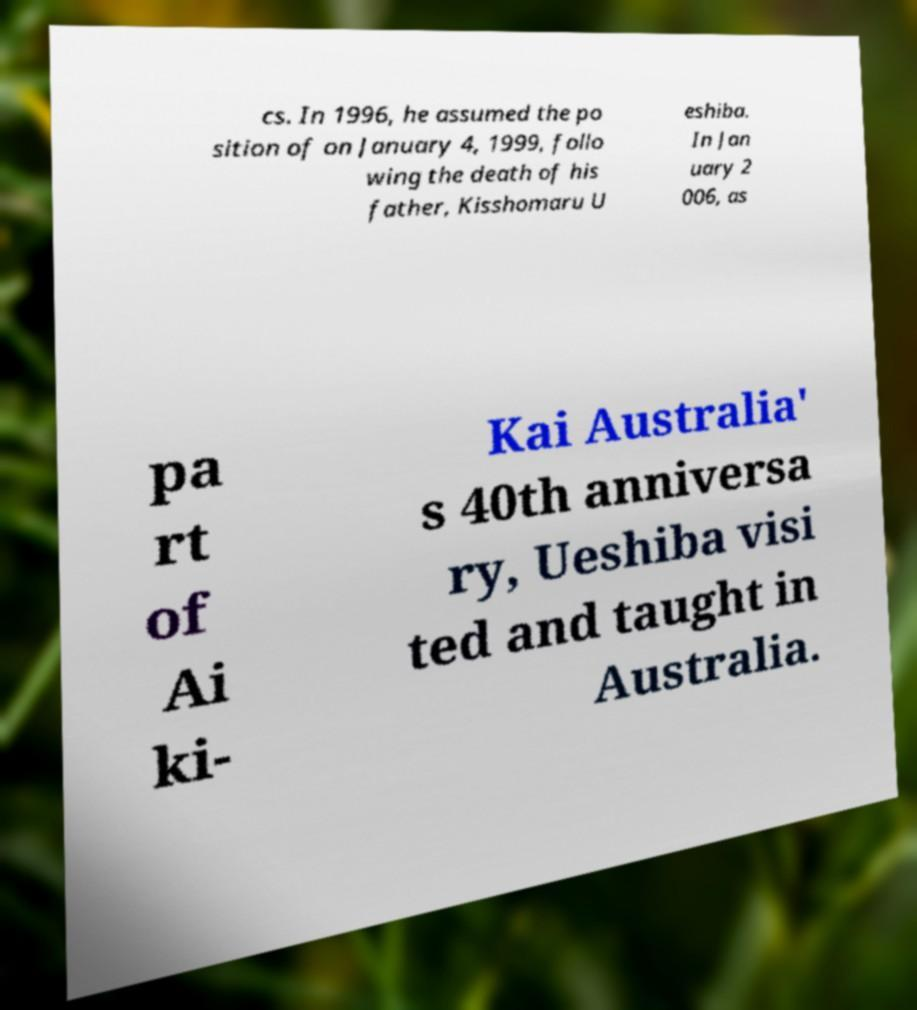I need the written content from this picture converted into text. Can you do that? cs. In 1996, he assumed the po sition of on January 4, 1999, follo wing the death of his father, Kisshomaru U eshiba. In Jan uary 2 006, as pa rt of Ai ki- Kai Australia' s 40th anniversa ry, Ueshiba visi ted and taught in Australia. 